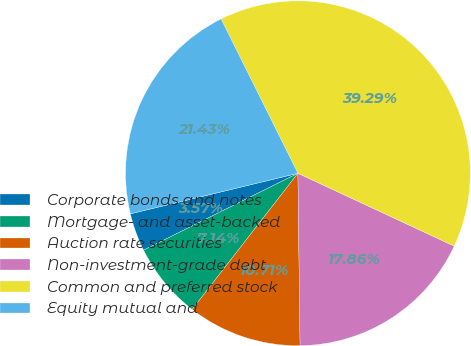Convert chart. <chart><loc_0><loc_0><loc_500><loc_500><pie_chart><fcel>Corporate bonds and notes<fcel>Mortgage- and asset-backed<fcel>Auction rate securities<fcel>Non-investment-grade debt<fcel>Common and preferred stock<fcel>Equity mutual and<nl><fcel>3.57%<fcel>7.14%<fcel>10.71%<fcel>17.86%<fcel>39.29%<fcel>21.43%<nl></chart> 